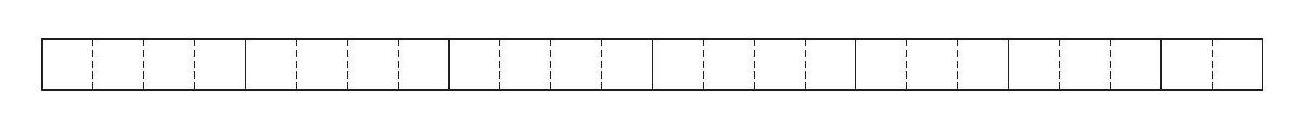What if we used the pieces to form a different shape, not a rectangle—would the perimeter change? The problem specifically asks for the pieces to be arranged into another rectangle. If we were to form a different shape, the perimeter could indeed change, but this would not answer the original question. Additionally, when arranging rectangles, typically the most compact shape you can form is another rectangle. 